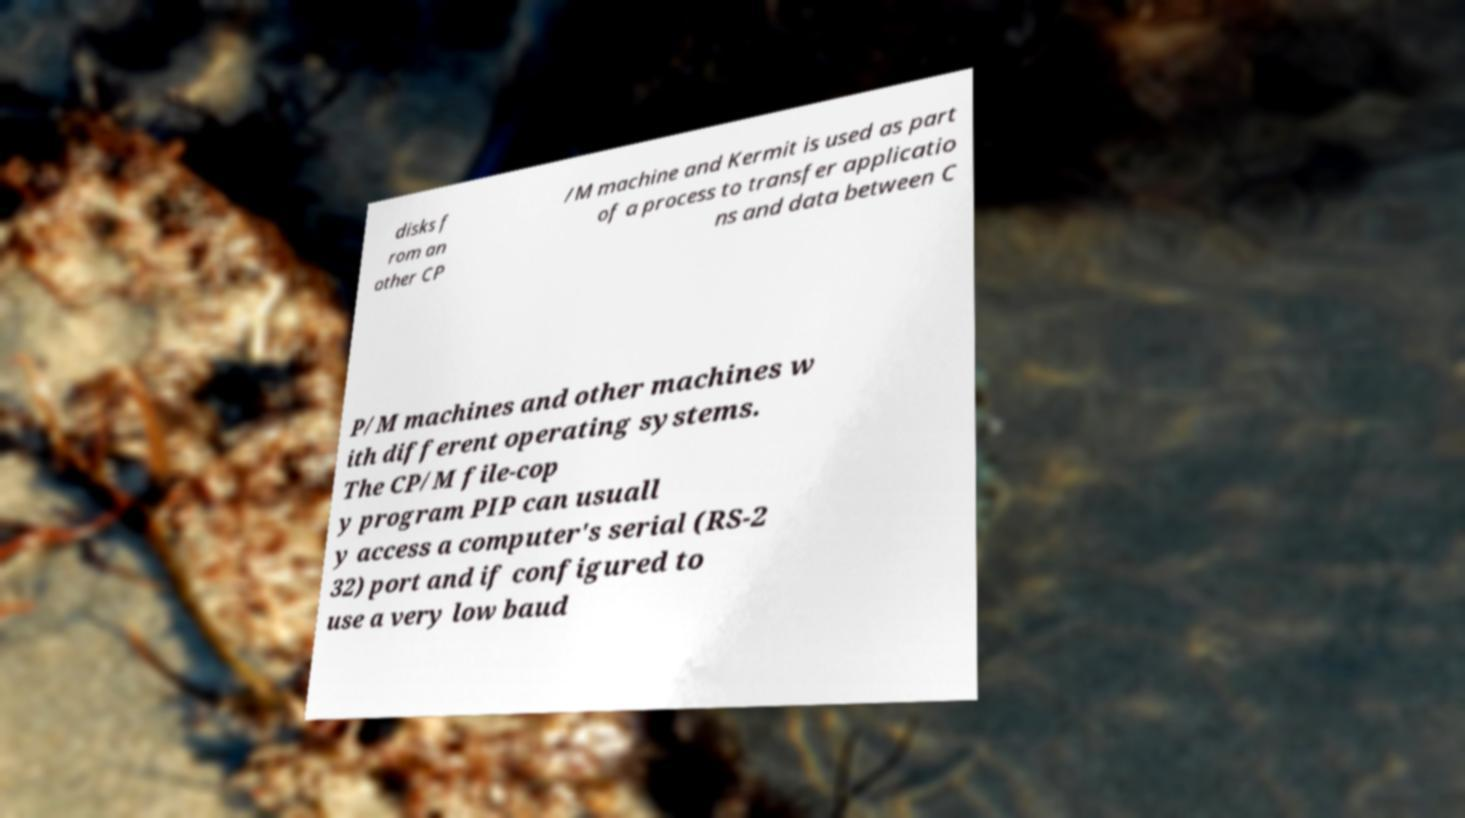Could you extract and type out the text from this image? disks f rom an other CP /M machine and Kermit is used as part of a process to transfer applicatio ns and data between C P/M machines and other machines w ith different operating systems. The CP/M file-cop y program PIP can usuall y access a computer's serial (RS-2 32) port and if configured to use a very low baud 